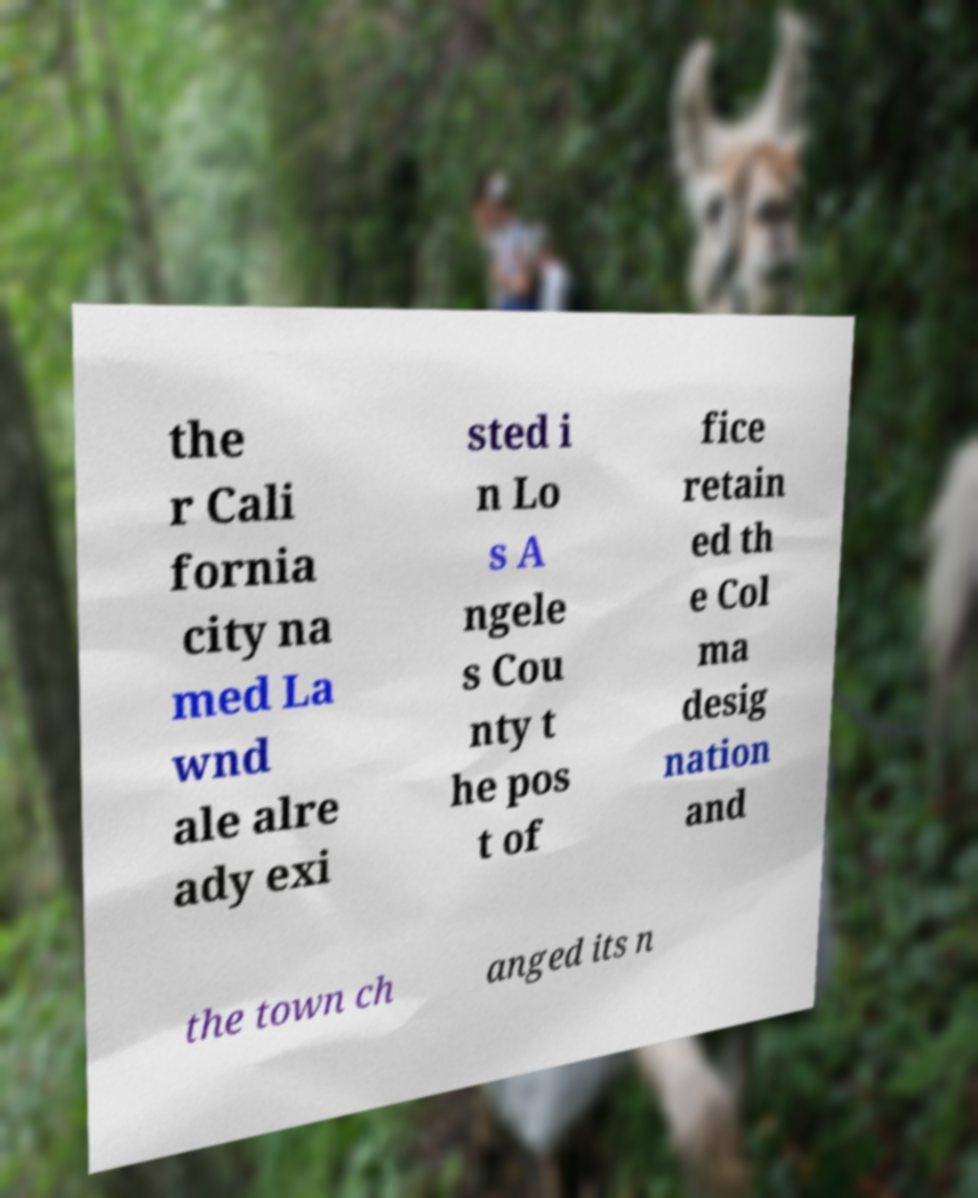There's text embedded in this image that I need extracted. Can you transcribe it verbatim? the r Cali fornia city na med La wnd ale alre ady exi sted i n Lo s A ngele s Cou nty t he pos t of fice retain ed th e Col ma desig nation and the town ch anged its n 